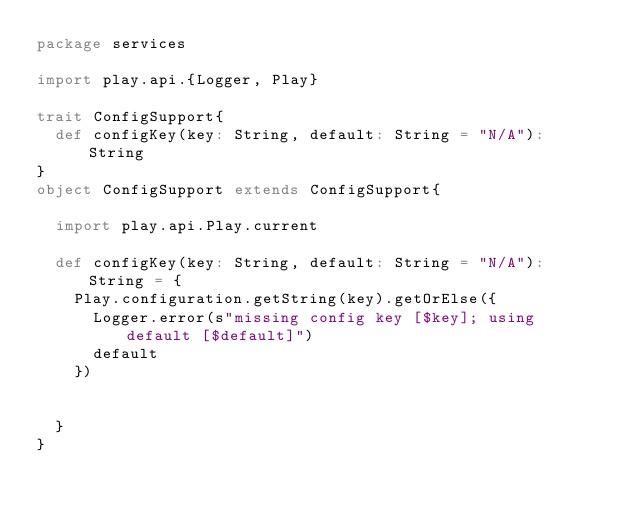Convert code to text. <code><loc_0><loc_0><loc_500><loc_500><_Scala_>package services

import play.api.{Logger, Play}

trait ConfigSupport{
  def configKey(key: String, default: String = "N/A"): String
}
object ConfigSupport extends ConfigSupport{

  import play.api.Play.current

  def configKey(key: String, default: String = "N/A"): String = {
    Play.configuration.getString(key).getOrElse({
      Logger.error(s"missing config key [$key]; using default [$default]")
      default
    })


  }
}</code> 